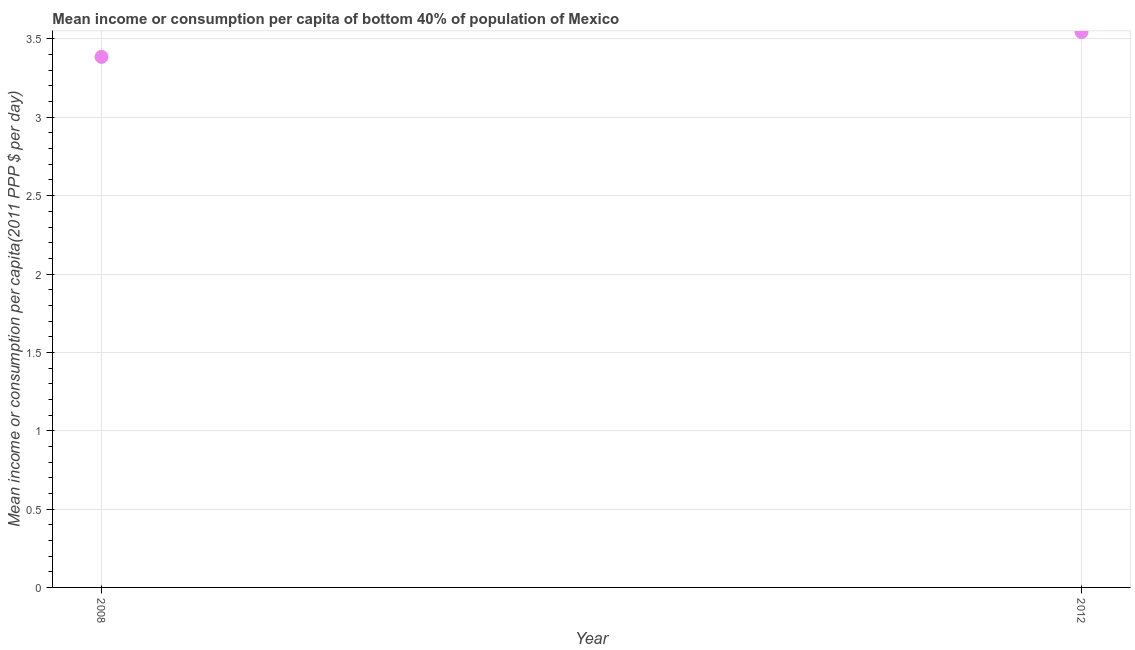What is the mean income or consumption in 2008?
Your response must be concise. 3.39. Across all years, what is the maximum mean income or consumption?
Provide a short and direct response. 3.54. Across all years, what is the minimum mean income or consumption?
Provide a short and direct response. 3.39. In which year was the mean income or consumption minimum?
Ensure brevity in your answer.  2008. What is the sum of the mean income or consumption?
Offer a terse response. 6.93. What is the difference between the mean income or consumption in 2008 and 2012?
Provide a succinct answer. -0.16. What is the average mean income or consumption per year?
Provide a short and direct response. 3.46. What is the median mean income or consumption?
Your response must be concise. 3.46. In how many years, is the mean income or consumption greater than 0.9 $?
Provide a succinct answer. 2. Do a majority of the years between 2012 and 2008 (inclusive) have mean income or consumption greater than 1.8 $?
Offer a very short reply. No. What is the ratio of the mean income or consumption in 2008 to that in 2012?
Keep it short and to the point. 0.96. Is the mean income or consumption in 2008 less than that in 2012?
Offer a very short reply. Yes. In how many years, is the mean income or consumption greater than the average mean income or consumption taken over all years?
Make the answer very short. 1. How many dotlines are there?
Offer a terse response. 1. How many years are there in the graph?
Ensure brevity in your answer.  2. Does the graph contain any zero values?
Give a very brief answer. No. Does the graph contain grids?
Keep it short and to the point. Yes. What is the title of the graph?
Ensure brevity in your answer.  Mean income or consumption per capita of bottom 40% of population of Mexico. What is the label or title of the Y-axis?
Provide a succinct answer. Mean income or consumption per capita(2011 PPP $ per day). What is the Mean income or consumption per capita(2011 PPP $ per day) in 2008?
Your answer should be very brief. 3.39. What is the Mean income or consumption per capita(2011 PPP $ per day) in 2012?
Give a very brief answer. 3.54. What is the difference between the Mean income or consumption per capita(2011 PPP $ per day) in 2008 and 2012?
Ensure brevity in your answer.  -0.16. What is the ratio of the Mean income or consumption per capita(2011 PPP $ per day) in 2008 to that in 2012?
Make the answer very short. 0.95. 